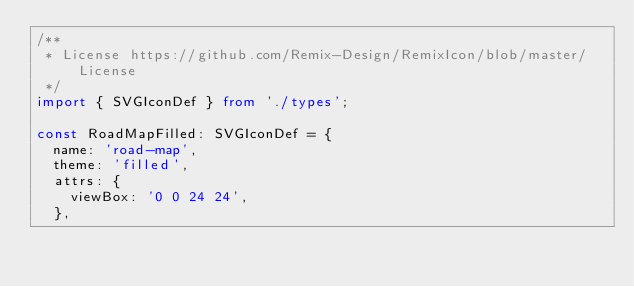<code> <loc_0><loc_0><loc_500><loc_500><_TypeScript_>/**
 * License https://github.com/Remix-Design/RemixIcon/blob/master/License
 */
import { SVGIconDef } from './types';

const RoadMapFilled: SVGIconDef = {
  name: 'road-map',
  theme: 'filled',
  attrs: {
    viewBox: '0 0 24 24',
  },</code> 